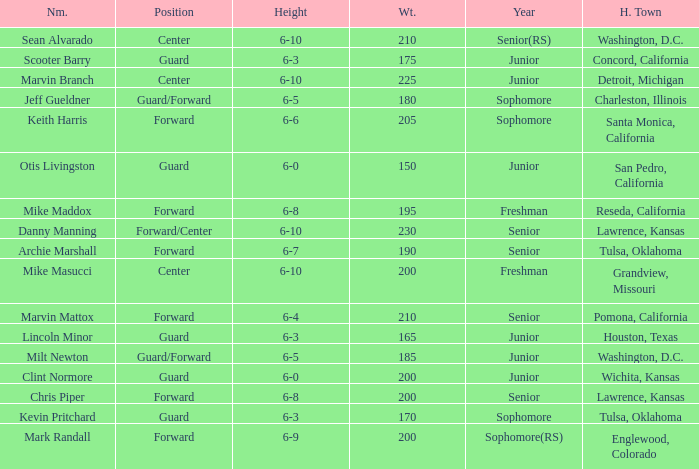Can you tell me the Name that has the Height of 6-5, and the Year of junior? Milt Newton. 